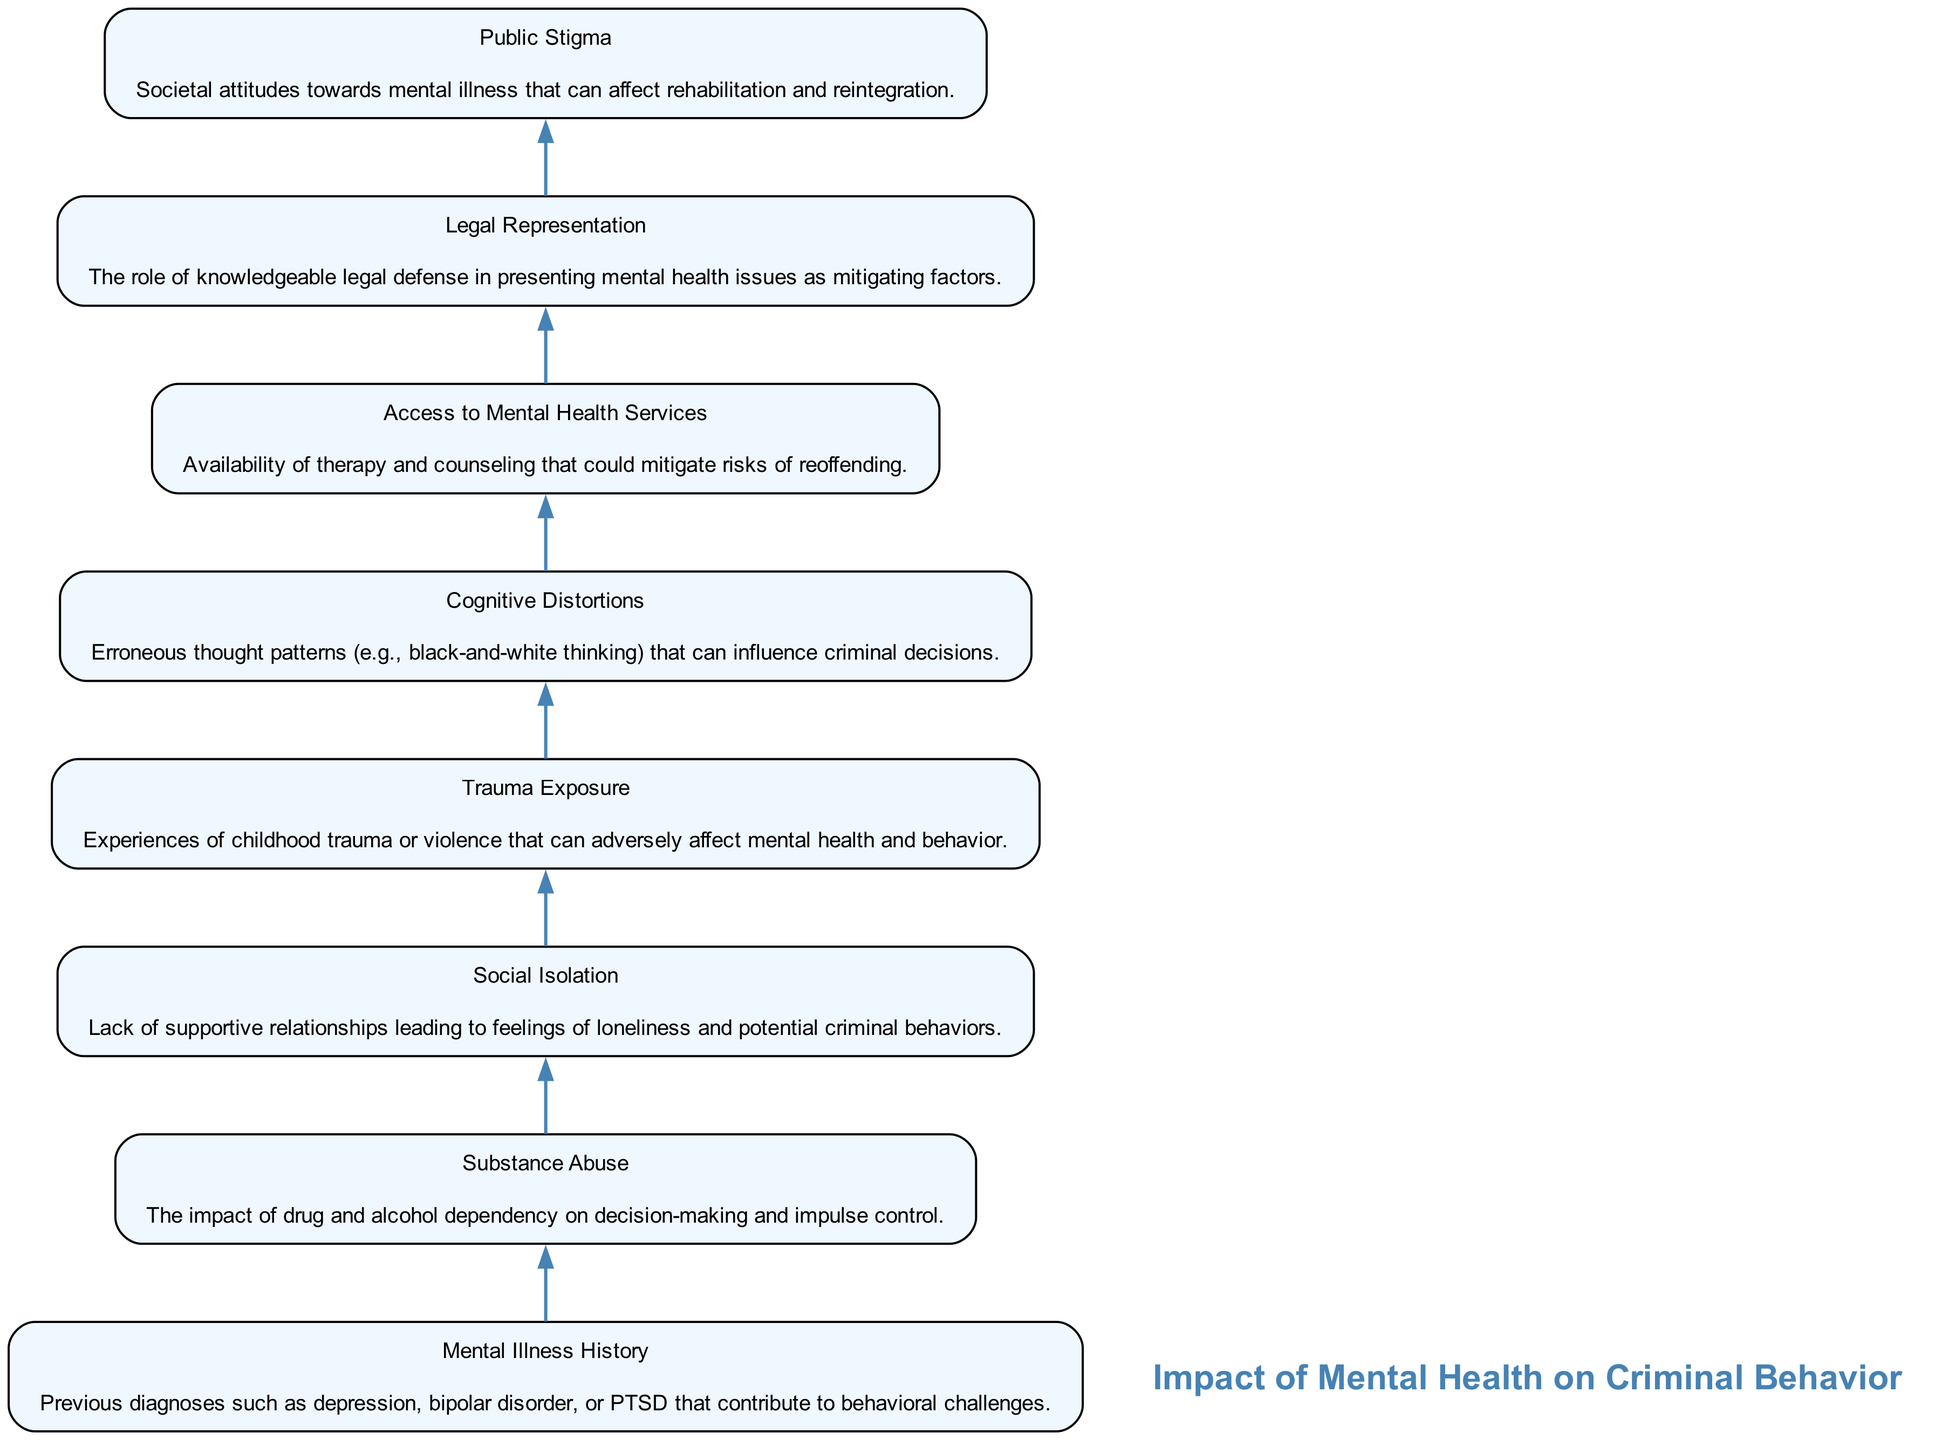What is the total number of nodes in the diagram? By counting the individual elements listed in the flow chart, there are eight distinct nodes in total, each representing a different factor in mental health and criminal behavior.
Answer: 8 What is the first node in the flow chart? The first node is labeled "Mental Illness History," which is the starting point of the flow representing the impact of mental health on criminal behavior.
Answer: Mental Illness History Which node describes the effect of lack of supportive relationships? The node describing this effect is "Social Isolation," which explains how the absence of supportive relationships can lead to criminal behavior.
Answer: Social Isolation What relationship exists between "Access to Mental Health Services" and "Legal Representation"? "Access to Mental Health Services" is positioned above "Legal Representation," indicating that having mental health services available can influence how effectively legal representation can present mental health issues during defense.
Answer: Access to Mental Health Services influences Legal Representation What does the "Trauma Exposure" node connect to? The "Trauma Exposure" node connects to the subsequent node of "Cognitive Distortions," suggesting that experiences of trauma can lead to erroneous thought patterns in an individual's decision-making.
Answer: Cognitive Distortions How many edges are present in the diagram? Each node, except the first, has a connection to the one immediately above it, making for a total of seven edges connecting the eight nodes in the flow chart.
Answer: 7 What two nodes are connected directly by an edge between "Substance Abuse" and "Cognitive Distortions"? "Substance Abuse" capitalizes on the notion of decision-making, which can lead to impulsive behaviors tied to "Cognitive Distortions," suggesting that substance abuse can exacerbate faulty thinking patterns.
Answer: Substance Abuse and Cognitive Distortions How does "Public Stigma" impact rehabilitative processes? The node labeled "Public Stigma" is situated towards the end of the flow, indicating that societal attitudes towards mental illness can hinder the process of rehabilitation and reintegration after criminal behavior.
Answer: Hinders rehabilitation What is the significance of the node "Access to Mental Health Services"? This node highlights the importance of therapy and counseling, indicating that improved accessibility to mental health services can help mitigate the risks of reoffending among individuals with mental health challenges.
Answer: Mitigates risks of reoffending 